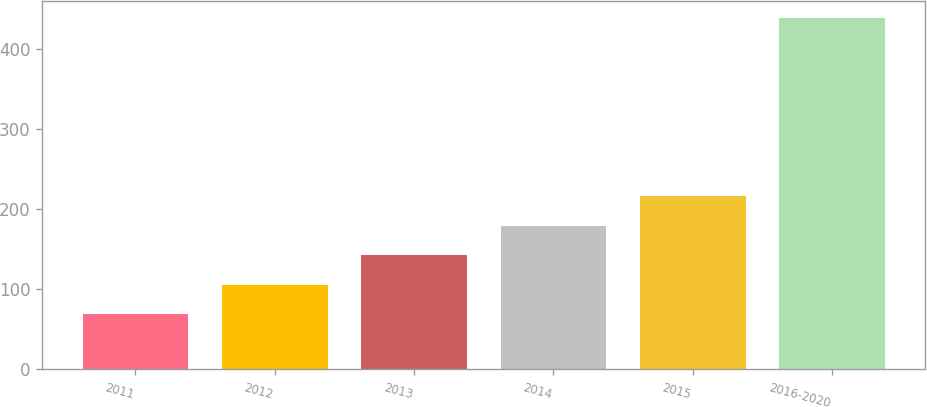Convert chart to OTSL. <chart><loc_0><loc_0><loc_500><loc_500><bar_chart><fcel>2011<fcel>2012<fcel>2013<fcel>2014<fcel>2015<fcel>2016-2020<nl><fcel>68.5<fcel>105.45<fcel>142.4<fcel>179.35<fcel>216.3<fcel>438<nl></chart> 